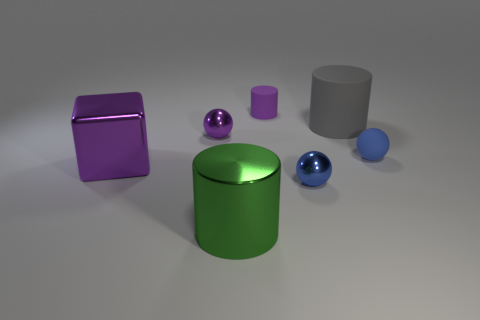Add 1 small balls. How many objects exist? 8 Subtract all cylinders. How many objects are left? 4 Subtract 0 cyan cubes. How many objects are left? 7 Subtract all gray rubber things. Subtract all small red spheres. How many objects are left? 6 Add 5 purple shiny spheres. How many purple shiny spheres are left? 6 Add 1 small purple matte things. How many small purple matte things exist? 2 